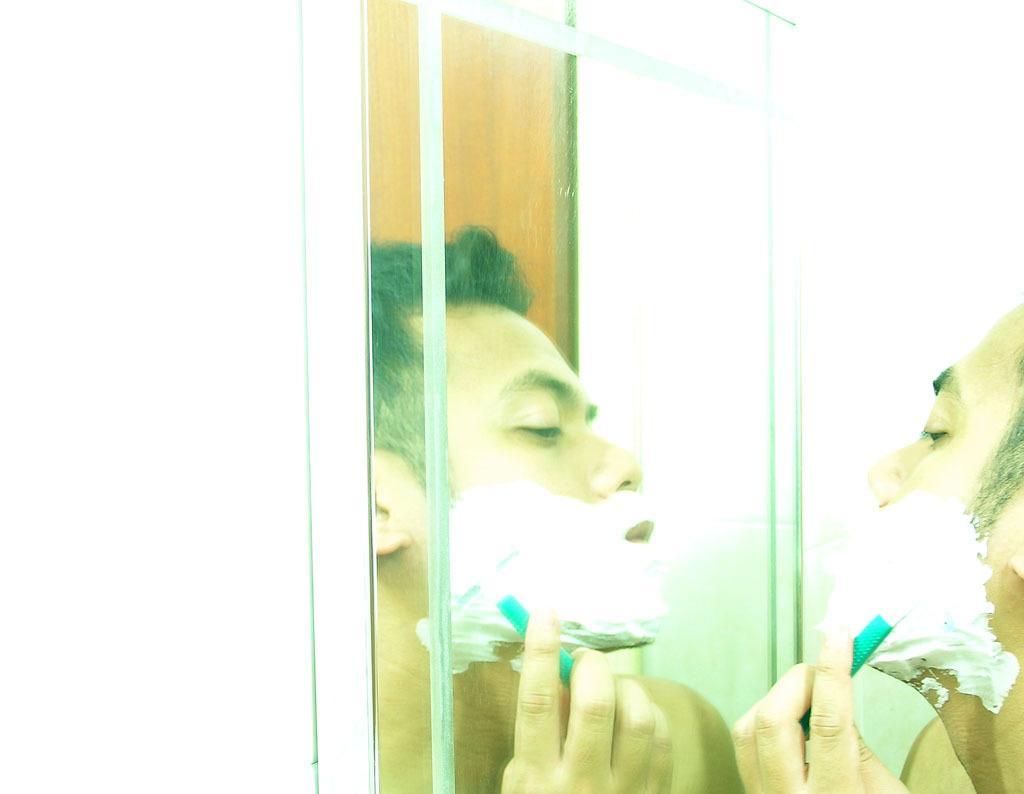Can you describe this image briefly? On the right side of the picture, we see the man is shaving his beard. In front of him, we see a mirror in which we can see a man shaving the beard. Behind him, we see a cupboard. In the background, we see a wall which is white in color. 